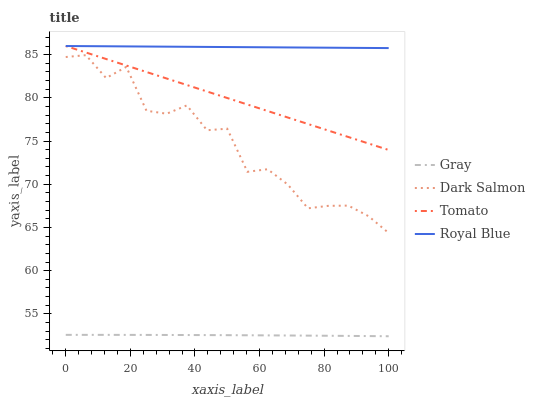Does Gray have the minimum area under the curve?
Answer yes or no. Yes. Does Royal Blue have the maximum area under the curve?
Answer yes or no. Yes. Does Dark Salmon have the minimum area under the curve?
Answer yes or no. No. Does Dark Salmon have the maximum area under the curve?
Answer yes or no. No. Is Tomato the smoothest?
Answer yes or no. Yes. Is Dark Salmon the roughest?
Answer yes or no. Yes. Is Gray the smoothest?
Answer yes or no. No. Is Gray the roughest?
Answer yes or no. No. Does Gray have the lowest value?
Answer yes or no. Yes. Does Dark Salmon have the lowest value?
Answer yes or no. No. Does Royal Blue have the highest value?
Answer yes or no. Yes. Does Dark Salmon have the highest value?
Answer yes or no. No. Is Gray less than Dark Salmon?
Answer yes or no. Yes. Is Dark Salmon greater than Gray?
Answer yes or no. Yes. Does Royal Blue intersect Tomato?
Answer yes or no. Yes. Is Royal Blue less than Tomato?
Answer yes or no. No. Is Royal Blue greater than Tomato?
Answer yes or no. No. Does Gray intersect Dark Salmon?
Answer yes or no. No. 